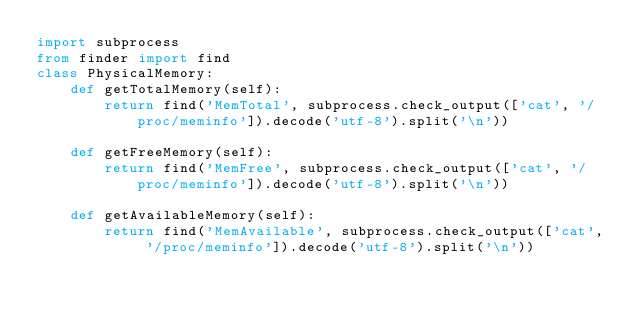<code> <loc_0><loc_0><loc_500><loc_500><_Python_>import subprocess
from finder import find
class PhysicalMemory:
	def getTotalMemory(self):
		return find('MemTotal', subprocess.check_output(['cat', '/proc/meminfo']).decode('utf-8').split('\n'))

	def getFreeMemory(self):
		return find('MemFree', subprocess.check_output(['cat', '/proc/meminfo']).decode('utf-8').split('\n'))
		
	def getAvailableMemory(self):
		return find('MemAvailable', subprocess.check_output(['cat', '/proc/meminfo']).decode('utf-8').split('\n'))
</code> 